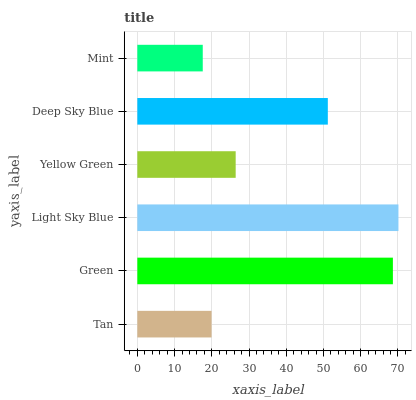Is Mint the minimum?
Answer yes or no. Yes. Is Light Sky Blue the maximum?
Answer yes or no. Yes. Is Green the minimum?
Answer yes or no. No. Is Green the maximum?
Answer yes or no. No. Is Green greater than Tan?
Answer yes or no. Yes. Is Tan less than Green?
Answer yes or no. Yes. Is Tan greater than Green?
Answer yes or no. No. Is Green less than Tan?
Answer yes or no. No. Is Deep Sky Blue the high median?
Answer yes or no. Yes. Is Yellow Green the low median?
Answer yes or no. Yes. Is Tan the high median?
Answer yes or no. No. Is Tan the low median?
Answer yes or no. No. 